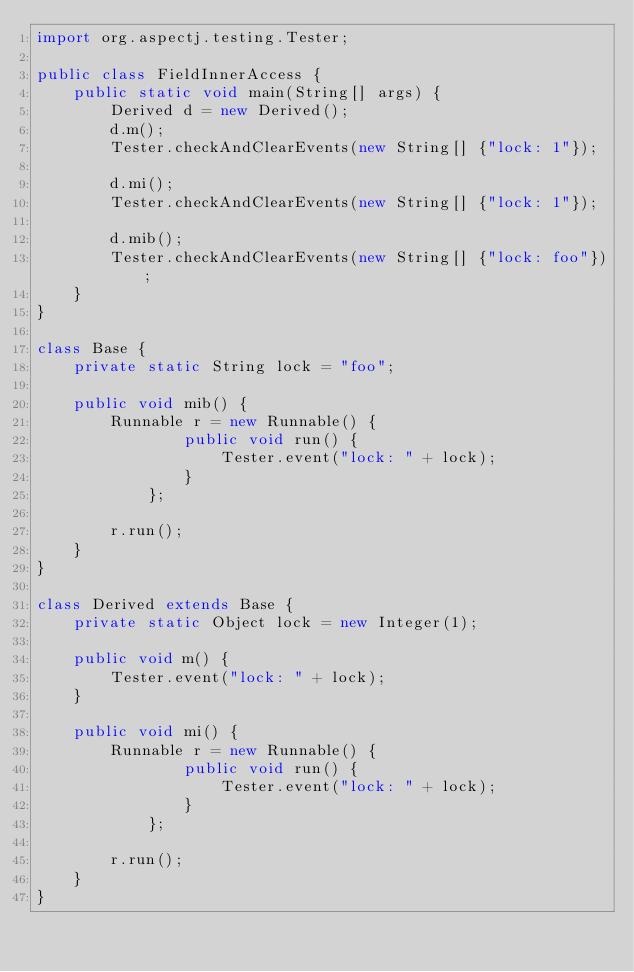Convert code to text. <code><loc_0><loc_0><loc_500><loc_500><_Java_>import org.aspectj.testing.Tester;

public class FieldInnerAccess {
    public static void main(String[] args) {
        Derived d = new Derived();
        d.m();
        Tester.checkAndClearEvents(new String[] {"lock: 1"});

        d.mi();
        Tester.checkAndClearEvents(new String[] {"lock: 1"});

        d.mib();
        Tester.checkAndClearEvents(new String[] {"lock: foo"});
    }
}

class Base {
    private static String lock = "foo";

    public void mib() {
        Runnable r = new Runnable() {
                public void run() {
                    Tester.event("lock: " + lock);
                }
            };

        r.run();
    }
}

class Derived extends Base {
    private static Object lock = new Integer(1);

    public void m() {
        Tester.event("lock: " + lock);
    }

    public void mi() {
        Runnable r = new Runnable() {
                public void run() {
                    Tester.event("lock: " + lock);
                }
            };

        r.run();
    }
}
</code> 